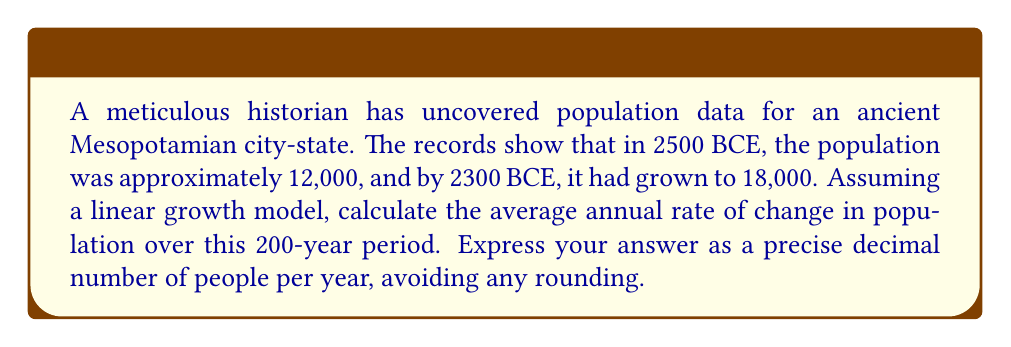What is the answer to this math problem? To solve this problem, we'll use the concept of rate of change in a linear equation. Let's approach this step-by-step:

1. Identify the key information:
   - Initial year: 2500 BCE
   - Initial population: 12,000
   - Final year: 2300 BCE
   - Final population: 18,000
   - Time period: 200 years

2. Set up the linear equation:
   Let $y$ represent the population and $x$ represent the number of years since 2500 BCE.
   The general form of a linear equation is:
   $$y = mx + b$$
   where $m$ is the slope (rate of change) and $b$ is the y-intercept (initial population).

3. Calculate the rate of change (slope):
   $$m = \frac{\text{change in y}}{\text{change in x}} = \frac{\text{change in population}}{\text{change in years}}$$
   $$m = \frac{18,000 - 12,000}{200} = \frac{6,000}{200} = 30$$

4. Verify the result:
   We can check our calculation by plugging in the values:
   $$y = 30x + 12,000$$
   For $x = 200$ (year 2300 BCE), we should get:
   $$y = 30(200) + 12,000 = 6,000 + 12,000 = 18,000$$
   This confirms our calculation is correct.

5. Interpret the result:
   The rate of change is 30 people per year, which represents the average annual increase in population over the 200-year period.
Answer: 30 